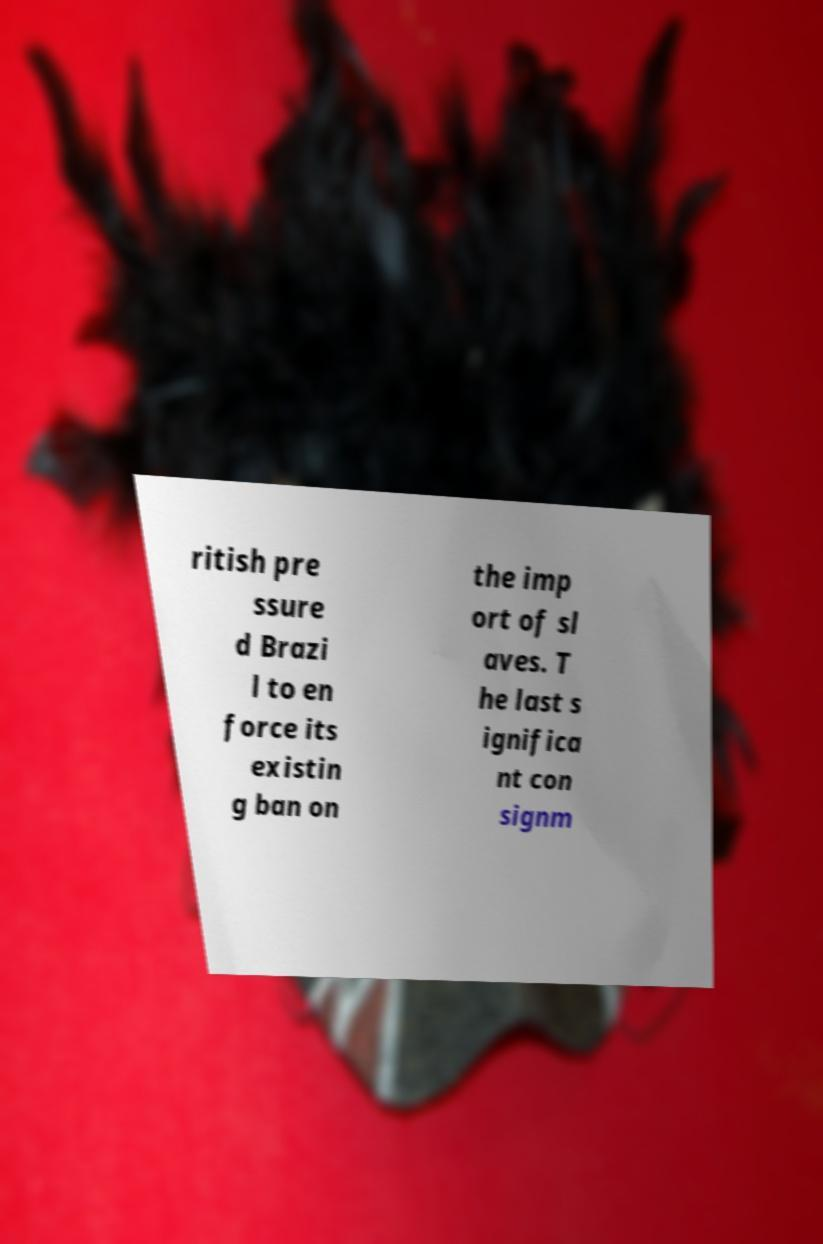Could you extract and type out the text from this image? ritish pre ssure d Brazi l to en force its existin g ban on the imp ort of sl aves. T he last s ignifica nt con signm 